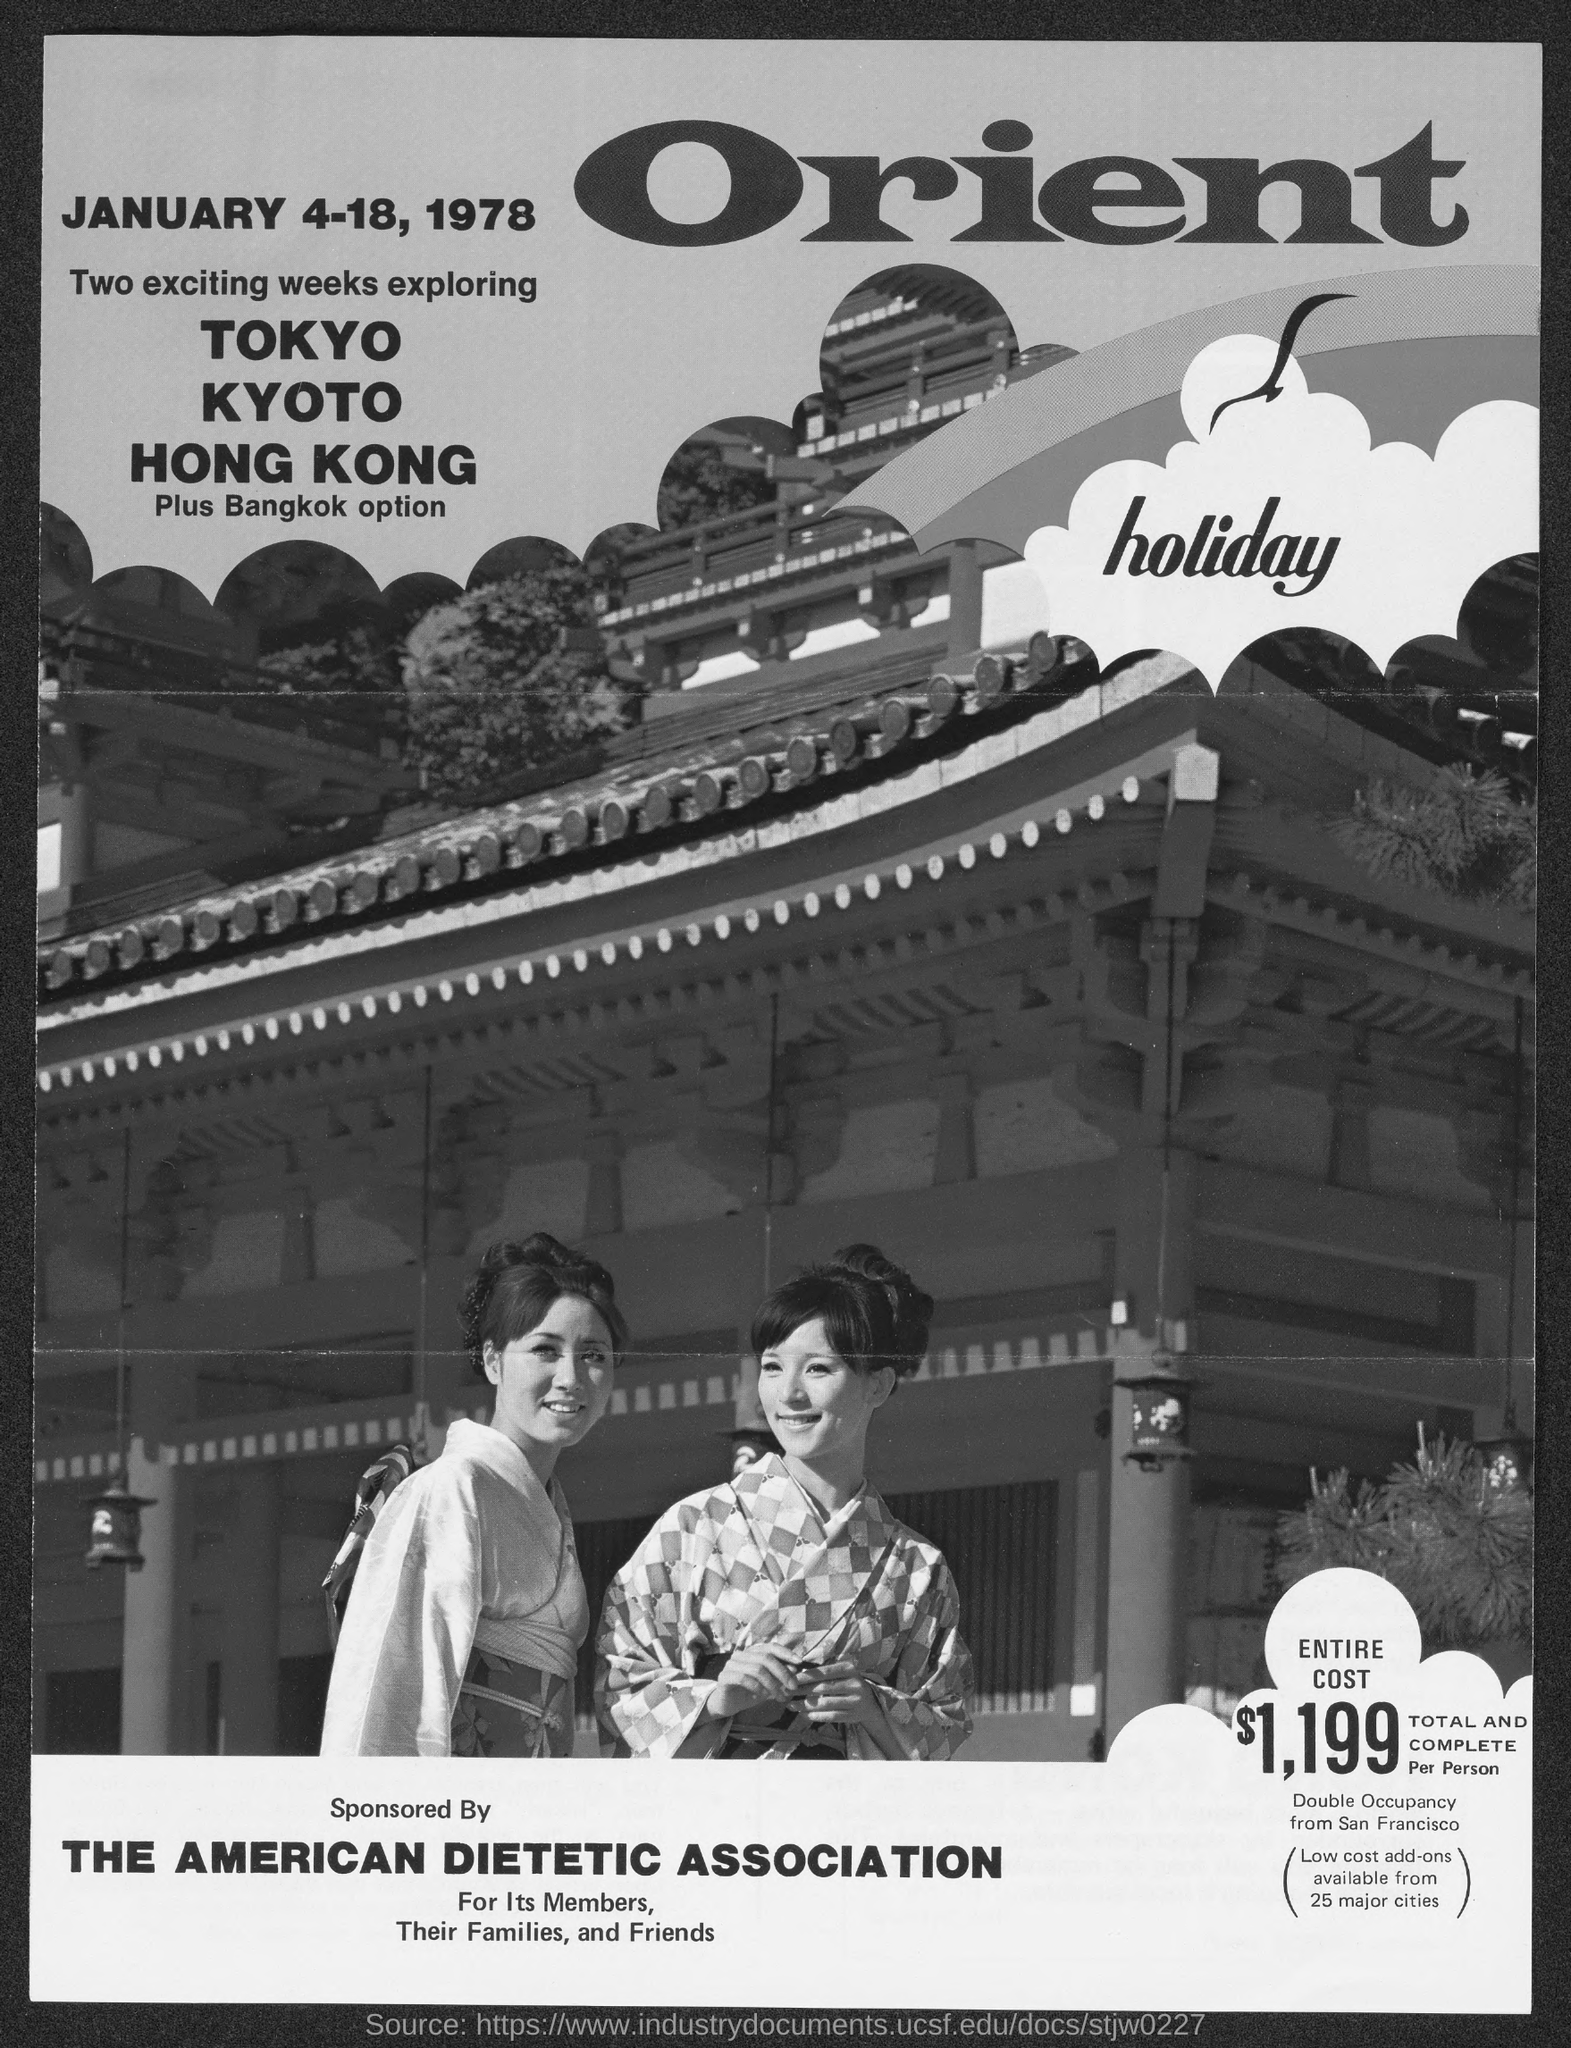What is the entire cost ?
Give a very brief answer. $1,199. 